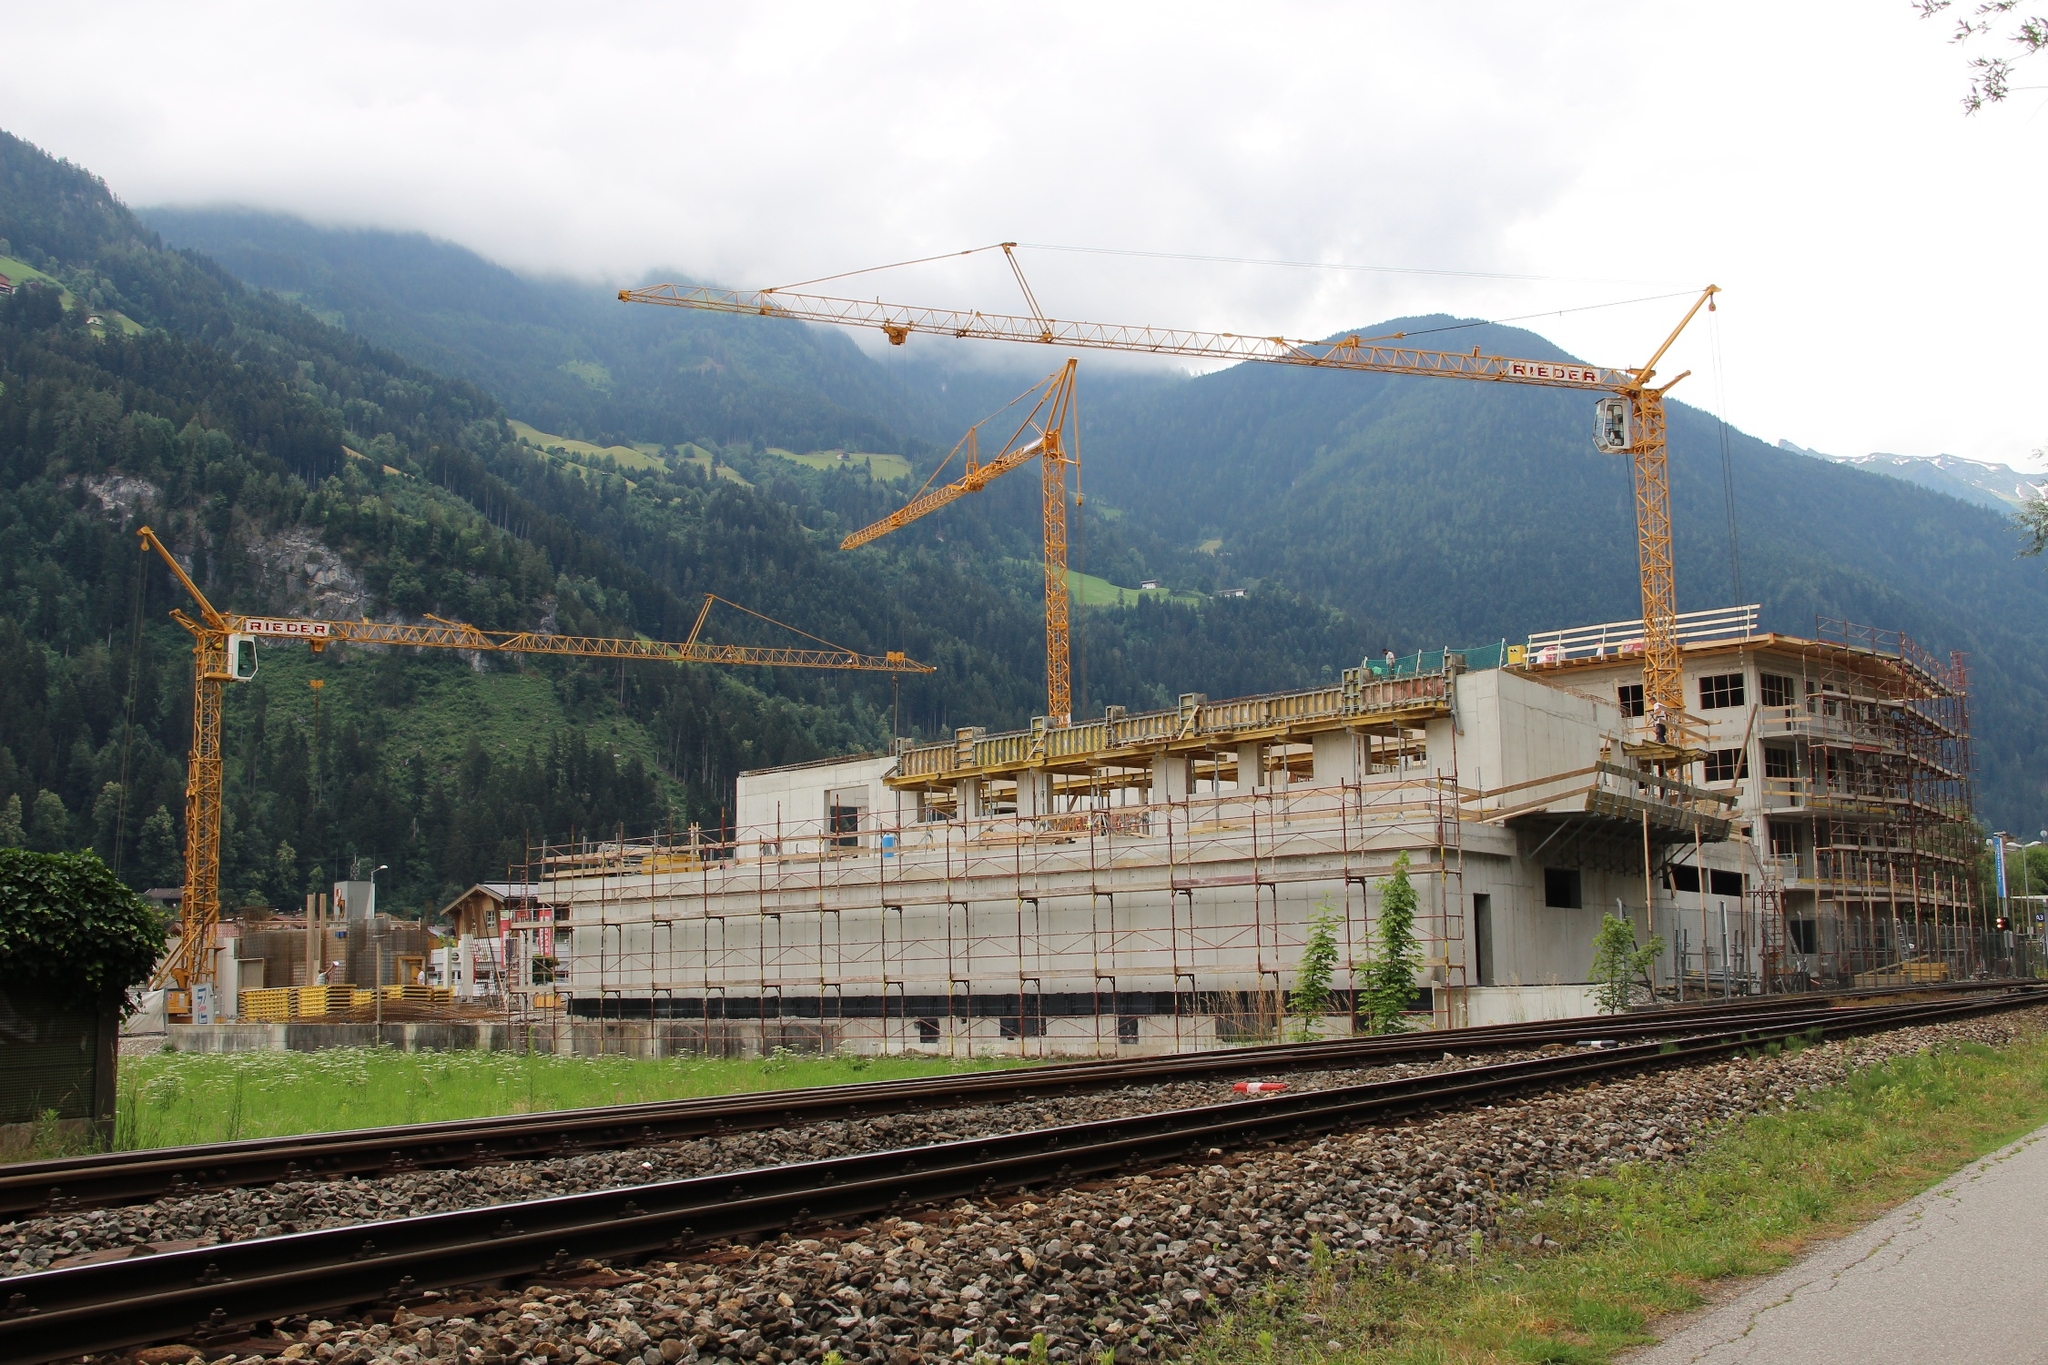What details stand out the most in this image? The details that stand out the most include the towering cranes actively engaged in the construction work, the extensive scaffolding around the building structure, and the stark contrast between the industrial activity and the lush green surroundings. The train track in the foreground also adds a unique element to the scene. 